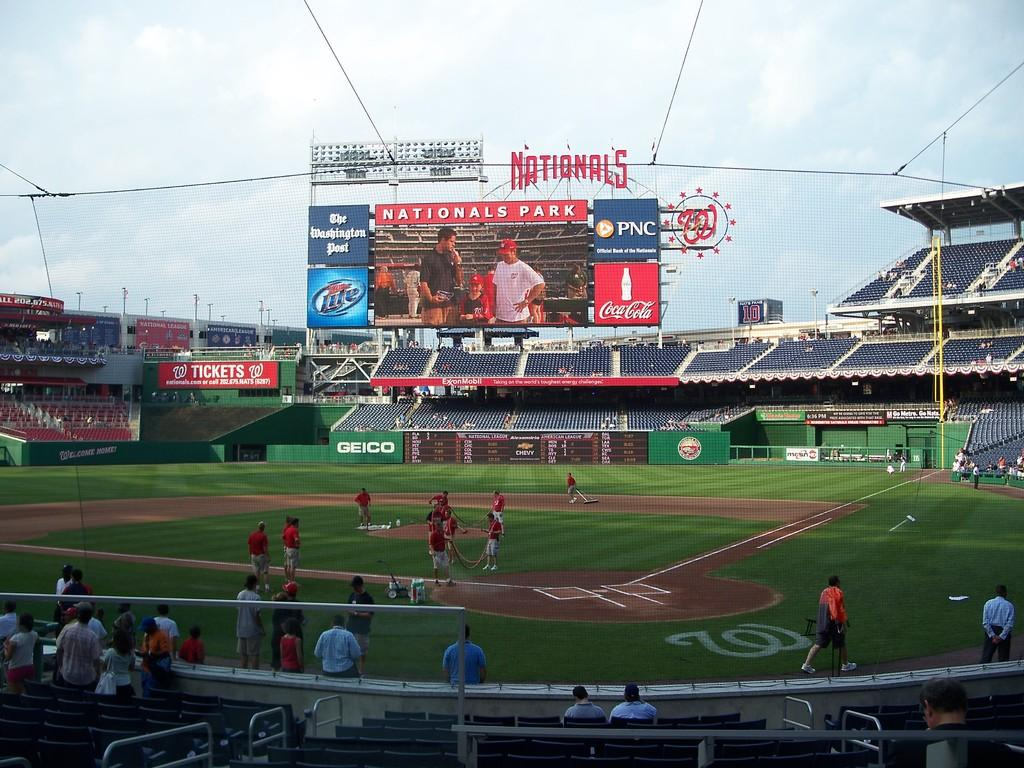<image>
Offer a succinct explanation of the picture presented. The screen at Nationals baseball park has a PNC sign and a Coca-cola sign on it. 